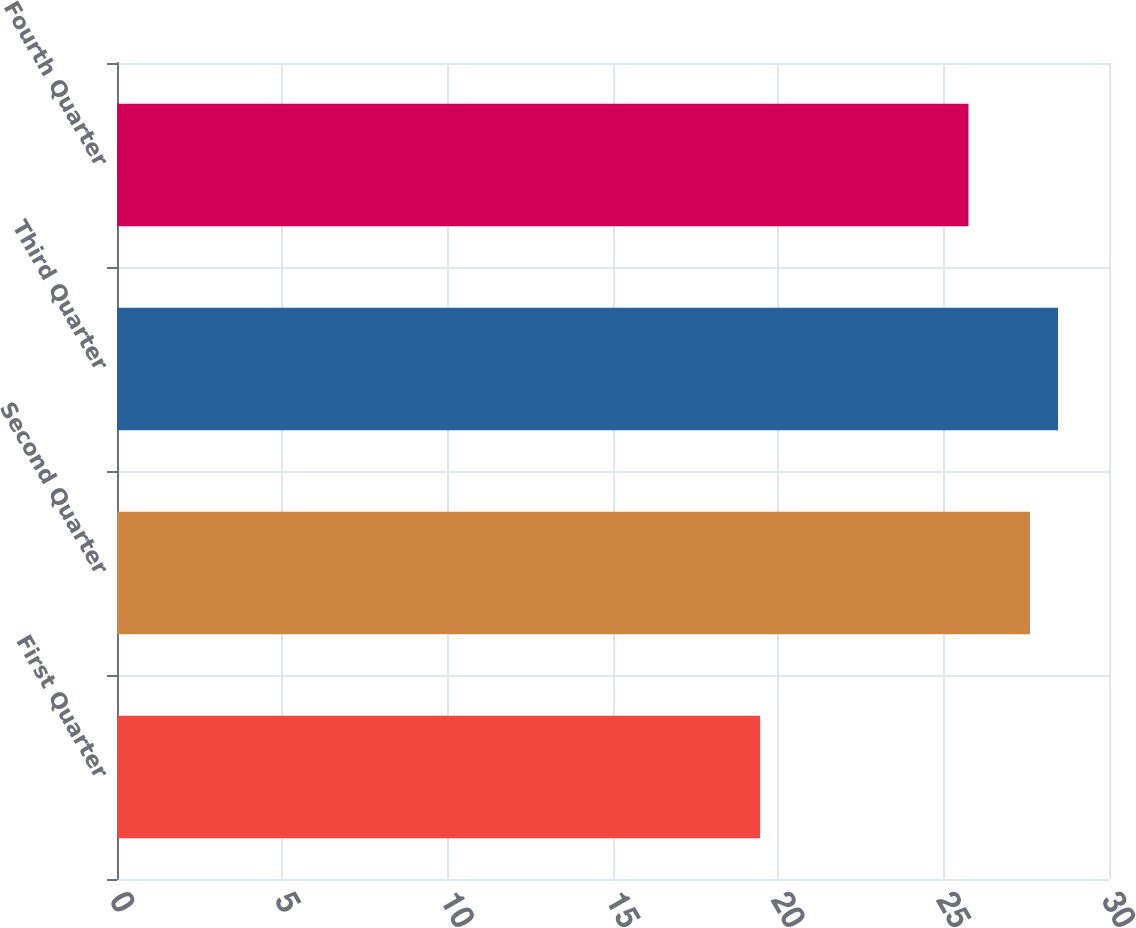Convert chart. <chart><loc_0><loc_0><loc_500><loc_500><bar_chart><fcel>First Quarter<fcel>Second Quarter<fcel>Third Quarter<fcel>Fourth Quarter<nl><fcel>19.45<fcel>27.61<fcel>28.46<fcel>25.75<nl></chart> 